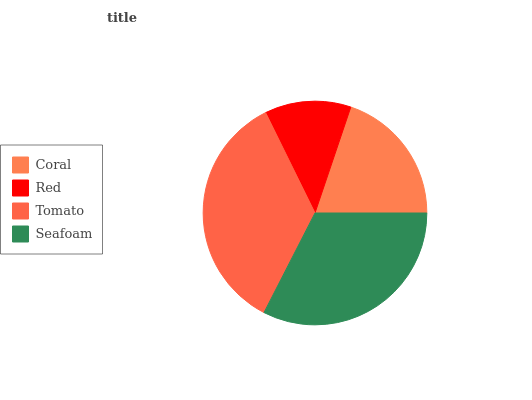Is Red the minimum?
Answer yes or no. Yes. Is Tomato the maximum?
Answer yes or no. Yes. Is Tomato the minimum?
Answer yes or no. No. Is Red the maximum?
Answer yes or no. No. Is Tomato greater than Red?
Answer yes or no. Yes. Is Red less than Tomato?
Answer yes or no. Yes. Is Red greater than Tomato?
Answer yes or no. No. Is Tomato less than Red?
Answer yes or no. No. Is Seafoam the high median?
Answer yes or no. Yes. Is Coral the low median?
Answer yes or no. Yes. Is Red the high median?
Answer yes or no. No. Is Tomato the low median?
Answer yes or no. No. 